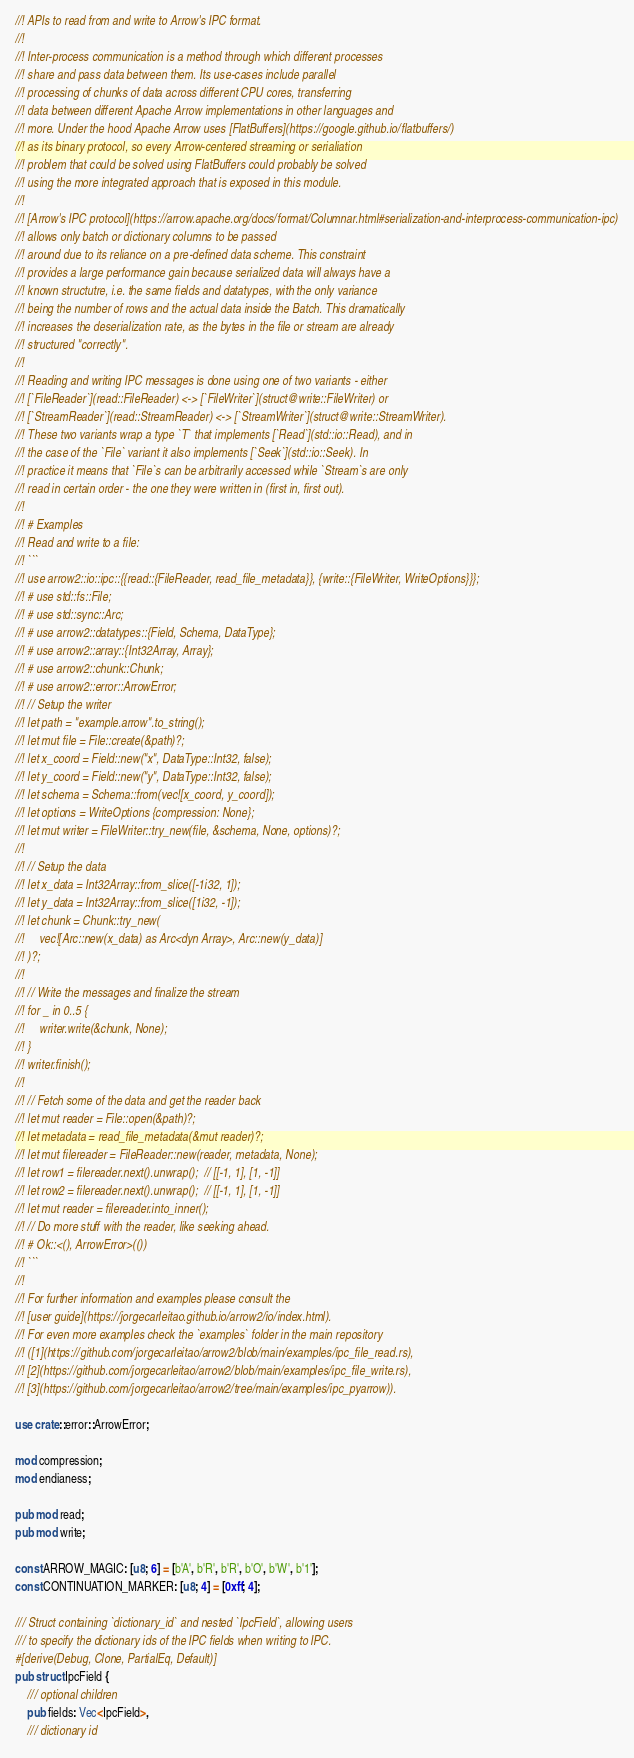<code> <loc_0><loc_0><loc_500><loc_500><_Rust_>//! APIs to read from and write to Arrow's IPC format.
//!
//! Inter-process communication is a method through which different processes
//! share and pass data between them. Its use-cases include parallel
//! processing of chunks of data across different CPU cores, transferring
//! data between different Apache Arrow implementations in other languages and
//! more. Under the hood Apache Arrow uses [FlatBuffers](https://google.github.io/flatbuffers/)
//! as its binary protocol, so every Arrow-centered streaming or serialiation
//! problem that could be solved using FlatBuffers could probably be solved
//! using the more integrated approach that is exposed in this module.
//!
//! [Arrow's IPC protocol](https://arrow.apache.org/docs/format/Columnar.html#serialization-and-interprocess-communication-ipc)
//! allows only batch or dictionary columns to be passed
//! around due to its reliance on a pre-defined data scheme. This constraint
//! provides a large performance gain because serialized data will always have a
//! known structutre, i.e. the same fields and datatypes, with the only variance
//! being the number of rows and the actual data inside the Batch. This dramatically
//! increases the deserialization rate, as the bytes in the file or stream are already
//! structured "correctly".
//!
//! Reading and writing IPC messages is done using one of two variants - either
//! [`FileReader`](read::FileReader) <-> [`FileWriter`](struct@write::FileWriter) or
//! [`StreamReader`](read::StreamReader) <-> [`StreamWriter`](struct@write::StreamWriter).
//! These two variants wrap a type `T` that implements [`Read`](std::io::Read), and in
//! the case of the `File` variant it also implements [`Seek`](std::io::Seek). In
//! practice it means that `File`s can be arbitrarily accessed while `Stream`s are only
//! read in certain order - the one they were written in (first in, first out).
//!
//! # Examples
//! Read and write to a file:
//! ```
//! use arrow2::io::ipc::{{read::{FileReader, read_file_metadata}}, {write::{FileWriter, WriteOptions}}};
//! # use std::fs::File;
//! # use std::sync::Arc;
//! # use arrow2::datatypes::{Field, Schema, DataType};
//! # use arrow2::array::{Int32Array, Array};
//! # use arrow2::chunk::Chunk;
//! # use arrow2::error::ArrowError;
//! // Setup the writer
//! let path = "example.arrow".to_string();
//! let mut file = File::create(&path)?;
//! let x_coord = Field::new("x", DataType::Int32, false);
//! let y_coord = Field::new("y", DataType::Int32, false);
//! let schema = Schema::from(vec![x_coord, y_coord]);
//! let options = WriteOptions {compression: None};
//! let mut writer = FileWriter::try_new(file, &schema, None, options)?;
//!
//! // Setup the data
//! let x_data = Int32Array::from_slice([-1i32, 1]);
//! let y_data = Int32Array::from_slice([1i32, -1]);
//! let chunk = Chunk::try_new(
//!     vec![Arc::new(x_data) as Arc<dyn Array>, Arc::new(y_data)]
//! )?;
//!
//! // Write the messages and finalize the stream
//! for _ in 0..5 {
//!     writer.write(&chunk, None);
//! }
//! writer.finish();
//!
//! // Fetch some of the data and get the reader back
//! let mut reader = File::open(&path)?;
//! let metadata = read_file_metadata(&mut reader)?;
//! let mut filereader = FileReader::new(reader, metadata, None);
//! let row1 = filereader.next().unwrap();  // [[-1, 1], [1, -1]]
//! let row2 = filereader.next().unwrap();  // [[-1, 1], [1, -1]]
//! let mut reader = filereader.into_inner();
//! // Do more stuff with the reader, like seeking ahead.
//! # Ok::<(), ArrowError>(())
//! ```
//!
//! For further information and examples please consult the
//! [user guide](https://jorgecarleitao.github.io/arrow2/io/index.html).
//! For even more examples check the `examples` folder in the main repository
//! ([1](https://github.com/jorgecarleitao/arrow2/blob/main/examples/ipc_file_read.rs),
//! [2](https://github.com/jorgecarleitao/arrow2/blob/main/examples/ipc_file_write.rs),
//! [3](https://github.com/jorgecarleitao/arrow2/tree/main/examples/ipc_pyarrow)).

use crate::error::ArrowError;

mod compression;
mod endianess;

pub mod read;
pub mod write;

const ARROW_MAGIC: [u8; 6] = [b'A', b'R', b'R', b'O', b'W', b'1'];
const CONTINUATION_MARKER: [u8; 4] = [0xff; 4];

/// Struct containing `dictionary_id` and nested `IpcField`, allowing users
/// to specify the dictionary ids of the IPC fields when writing to IPC.
#[derive(Debug, Clone, PartialEq, Default)]
pub struct IpcField {
    /// optional children
    pub fields: Vec<IpcField>,
    /// dictionary id</code> 